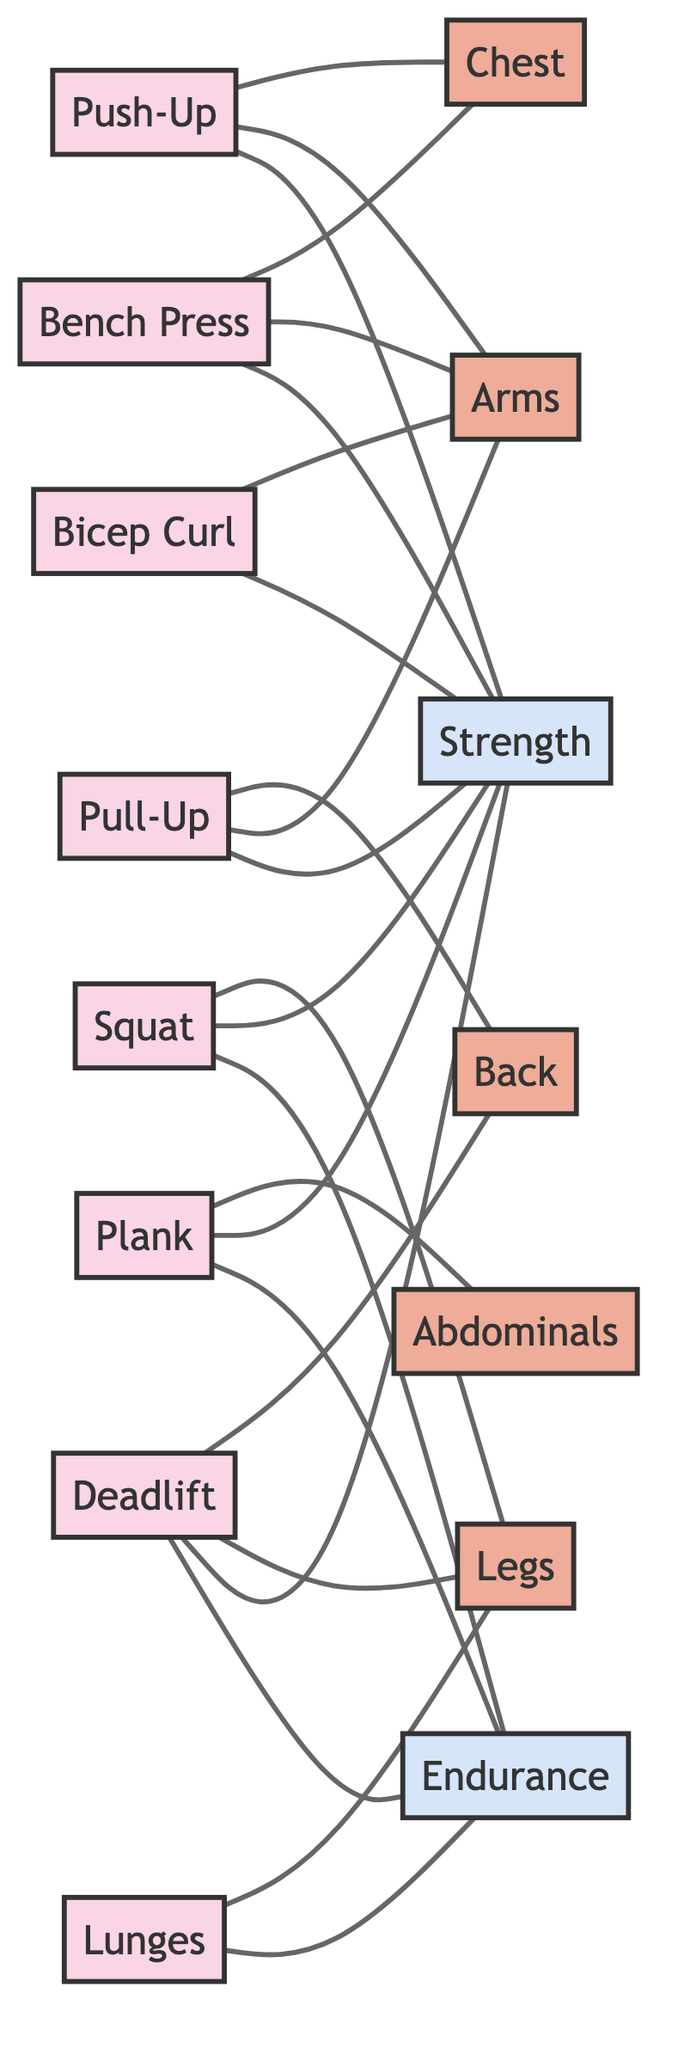What muscle groups are targeted by the Deadlift? The Deadlift is connected to the Back and Legs in the diagram. By following the edges from the Deadlift exercise node, we can see that it connects to both muscle nodes.
Answer: Back, Legs How many exercises focus on Strength as a benefit? By examining the edges connected to the Strength node, we identify that four exercises (Push-Up, Squat, Pull-Up, and Bench Press) target this benefit. Count the edges leading to Strength: there are four.
Answer: 4 What is the connection between Plank and Abdominals? The Plank directly connects to the Abdominals muscle group in the diagram. There is an edge indicating this relationship.
Answer: Yes How many total nodes are present in the diagram? To find the total number of nodes, we count all unique nodes in the provided data. There are 15 nodes in total: 8 exercises, 5 muscle groups, and 2 benefits.
Answer: 15 Which exercises benefit Endurance? By looking for connections to the Endurance benefit node, we see that Squat, Plank, Deadlift, and Lunges connect to it. Count the edges: there are four exercises.
Answer: Squat, Plank, Deadlift, Lunges What muscle does the Bicep Curl exercise target? The Bicep Curl is connected to the Arms muscle group. Referring to the edges connected to Bicep Curl, we see it leads to Arms.
Answer: Arms Which exercise connects to the most muscle groups? By analyzing the connections, we find that the Push-Up and Bench Press both connect to two muscle groups (Chest and Arms). All other exercises connect to fewer muscle groups.
Answer: Push-Up, Bench Press Which exercise has no direct connection to any benefit? Looking at Bicep Curl, it connects only to the Arms muscle group and Strength as a benefit, indicating no direct connection to Endurance. No edges lead to the Endurance node for Bicep Curl.
Answer: Bicep Curl 